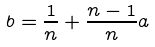<formula> <loc_0><loc_0><loc_500><loc_500>b = \frac { 1 } { n } + \frac { n - 1 } { n } a</formula> 